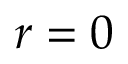Convert formula to latex. <formula><loc_0><loc_0><loc_500><loc_500>r = 0</formula> 